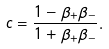<formula> <loc_0><loc_0><loc_500><loc_500>c = \frac { 1 - \beta _ { + } \beta _ { - } } { 1 + \beta _ { + } \beta _ { - } } .</formula> 